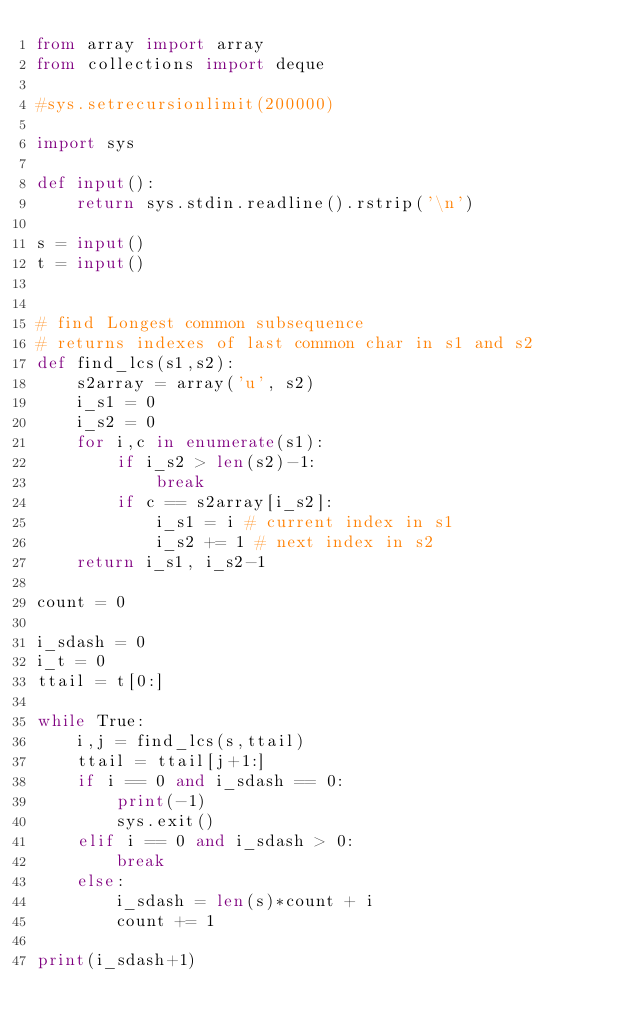<code> <loc_0><loc_0><loc_500><loc_500><_Python_>from array import array
from collections import deque

#sys.setrecursionlimit(200000)

import sys

def input():
    return sys.stdin.readline().rstrip('\n')

s = input()
t = input()


# find Longest common subsequence
# returns indexes of last common char in s1 and s2
def find_lcs(s1,s2):
    s2array = array('u', s2)
    i_s1 = 0
    i_s2 = 0
    for i,c in enumerate(s1):
        if i_s2 > len(s2)-1:
            break
        if c == s2array[i_s2]:
            i_s1 = i # current index in s1
            i_s2 += 1 # next index in s2
    return i_s1, i_s2-1

count = 0

i_sdash = 0
i_t = 0
ttail = t[0:]

while True:
    i,j = find_lcs(s,ttail)
    ttail = ttail[j+1:]
    if i == 0 and i_sdash == 0:
        print(-1)
        sys.exit()
    elif i == 0 and i_sdash > 0:
        break
    else:
        i_sdash = len(s)*count + i
        count += 1

print(i_sdash+1)
</code> 